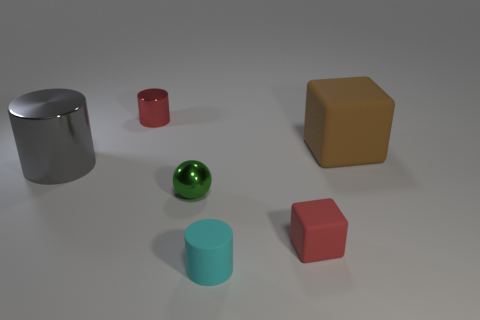What number of other objects are the same shape as the big brown matte object?
Keep it short and to the point. 1. How many things are metallic cylinders behind the big gray cylinder or small things in front of the green shiny thing?
Keep it short and to the point. 3. What number of other objects are the same color as the tiny matte block?
Your response must be concise. 1. Is the number of gray things that are to the right of the brown rubber thing less than the number of big shiny objects that are behind the big shiny object?
Provide a succinct answer. No. How many green shiny cylinders are there?
Provide a succinct answer. 0. Is there anything else that has the same material as the large gray thing?
Your answer should be very brief. Yes. What material is the other small thing that is the same shape as the cyan matte object?
Your response must be concise. Metal. Is the number of blocks that are to the left of the large gray cylinder less than the number of small green metallic objects?
Offer a very short reply. Yes. There is a rubber thing that is behind the large gray metal cylinder; is its shape the same as the green object?
Make the answer very short. No. Is there anything else that has the same color as the small sphere?
Your response must be concise. No. 